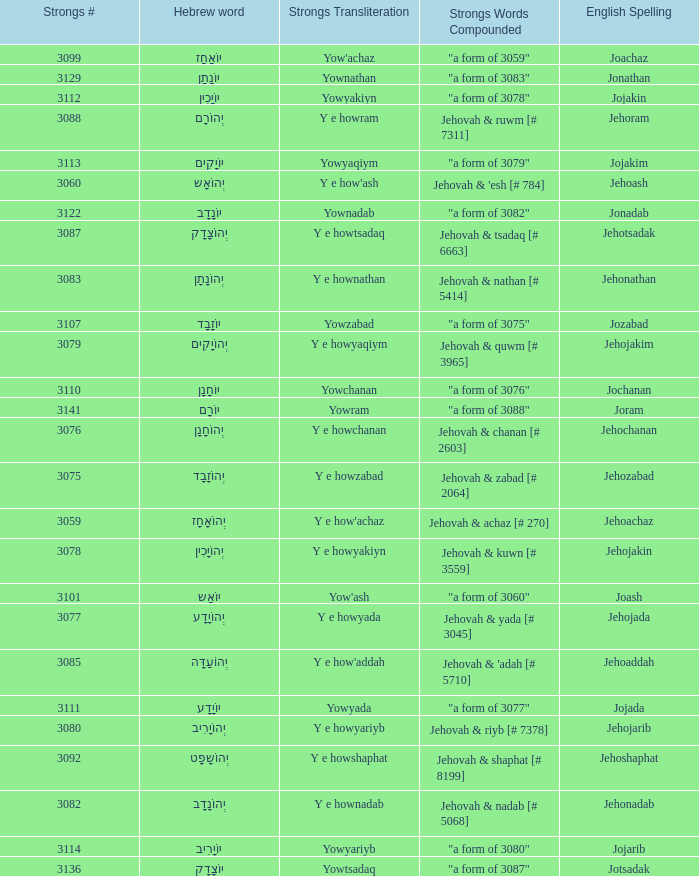How many strongs transliteration of the english spelling of the work jehojakin? 1.0. 